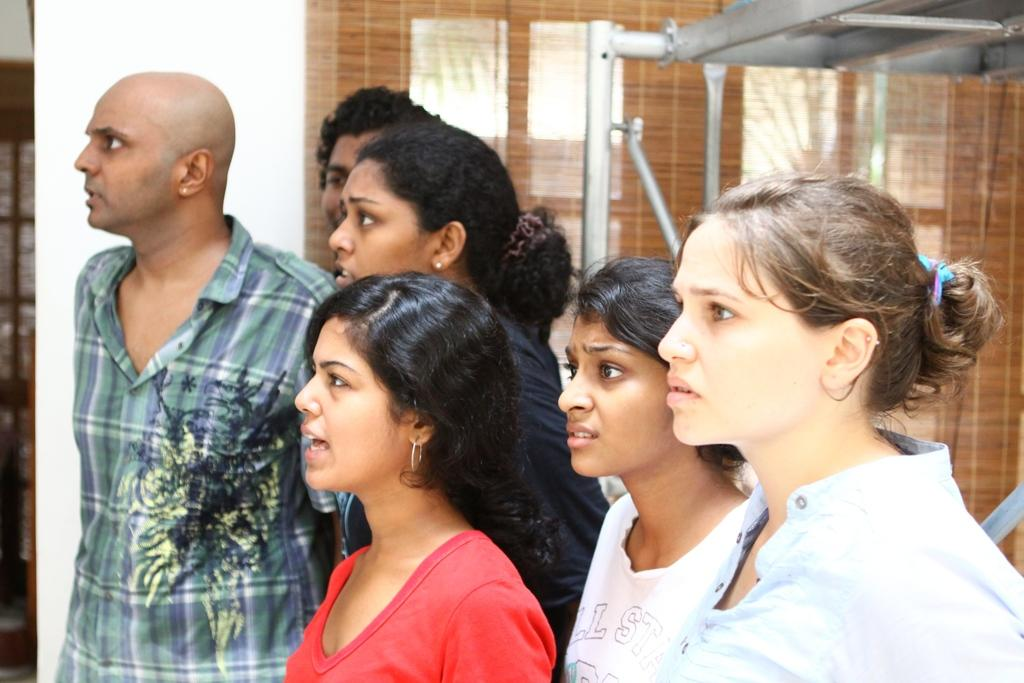Who or what can be seen in the image? There are people in the image. What is visible in the background of the image? There is a wall and a window with blinds in the background of the image. Can you describe the objects in the top right corner of the image? There are metallic objects in the top right corner of the image. What type of jewel is being taught in the class in the image? There is no class or jewel present in the image. What effect does the presence of the people have on the metallic objects in the image? The presence of the people does not have any effect on the metallic objects in the image, as they are separate entities. 